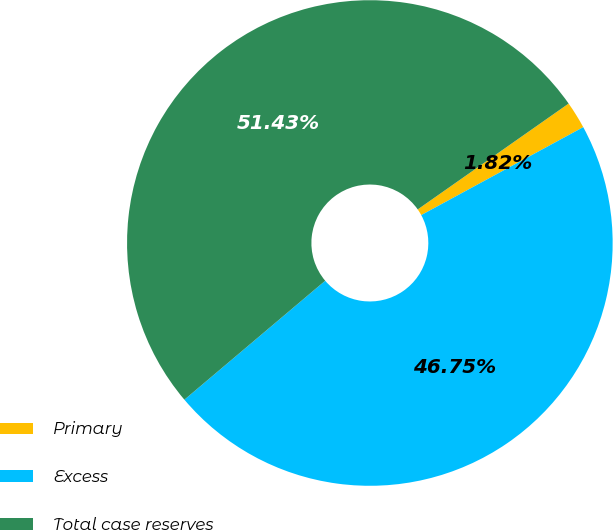Convert chart to OTSL. <chart><loc_0><loc_0><loc_500><loc_500><pie_chart><fcel>Primary<fcel>Excess<fcel>Total case reserves<nl><fcel>1.82%<fcel>46.75%<fcel>51.43%<nl></chart> 